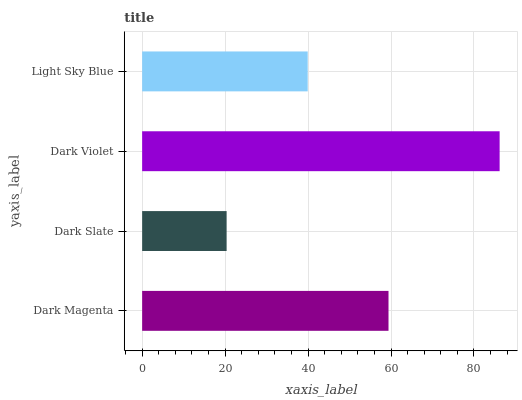Is Dark Slate the minimum?
Answer yes or no. Yes. Is Dark Violet the maximum?
Answer yes or no. Yes. Is Dark Violet the minimum?
Answer yes or no. No. Is Dark Slate the maximum?
Answer yes or no. No. Is Dark Violet greater than Dark Slate?
Answer yes or no. Yes. Is Dark Slate less than Dark Violet?
Answer yes or no. Yes. Is Dark Slate greater than Dark Violet?
Answer yes or no. No. Is Dark Violet less than Dark Slate?
Answer yes or no. No. Is Dark Magenta the high median?
Answer yes or no. Yes. Is Light Sky Blue the low median?
Answer yes or no. Yes. Is Dark Violet the high median?
Answer yes or no. No. Is Dark Violet the low median?
Answer yes or no. No. 